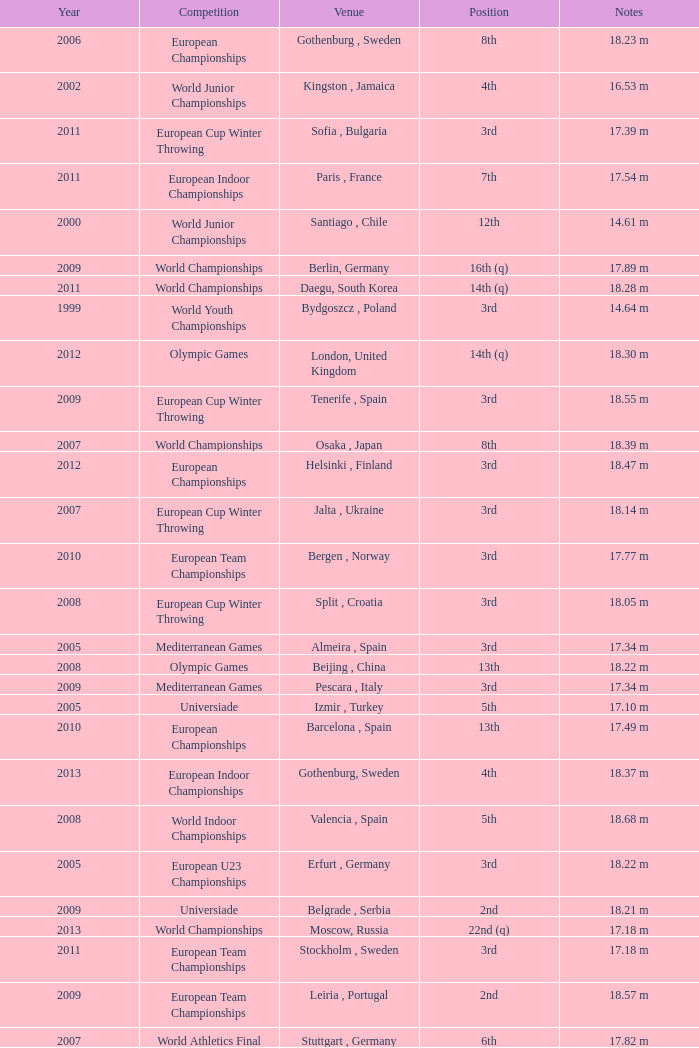What are the notes for bydgoszcz, Poland? 14.64 m, 16.49 m. 